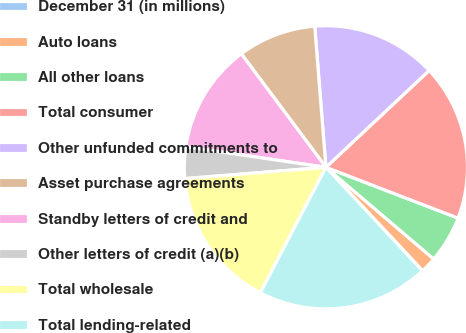Convert chart. <chart><loc_0><loc_0><loc_500><loc_500><pie_chart><fcel>December 31 (in millions)<fcel>Auto loans<fcel>All other loans<fcel>Total consumer<fcel>Other unfunded commitments to<fcel>Asset purchase agreements<fcel>Standby letters of credit and<fcel>Other letters of credit (a)(b)<fcel>Total wholesale<fcel>Total lending-related<nl><fcel>0.03%<fcel>1.81%<fcel>5.37%<fcel>17.83%<fcel>14.27%<fcel>8.93%<fcel>12.49%<fcel>3.59%<fcel>16.05%<fcel>19.61%<nl></chart> 